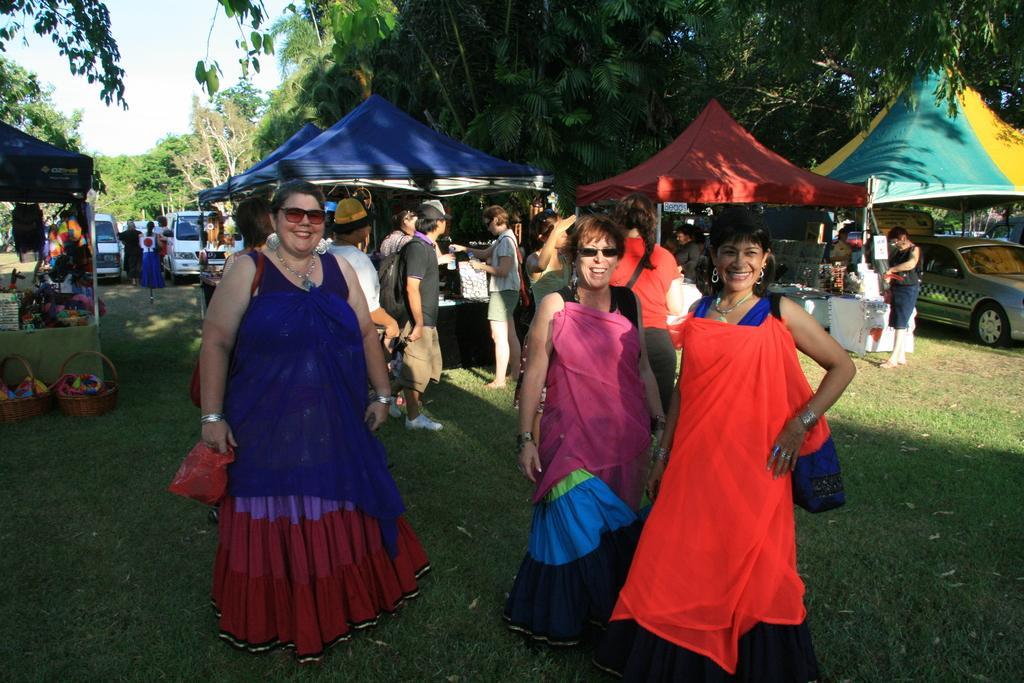In one or two sentences, can you explain what this image depicts? In this picture we can see three women smiling, standing on the grass and at the back of them we can see a group of people, tents, vehicles, trees, tables, baskets, some objects and in the background we can see the sky. 